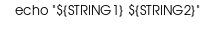<code> <loc_0><loc_0><loc_500><loc_500><_Bash_>
    echo "${STRING1} ${STRING2}"
    </code> 